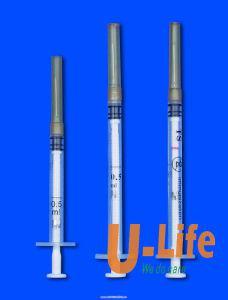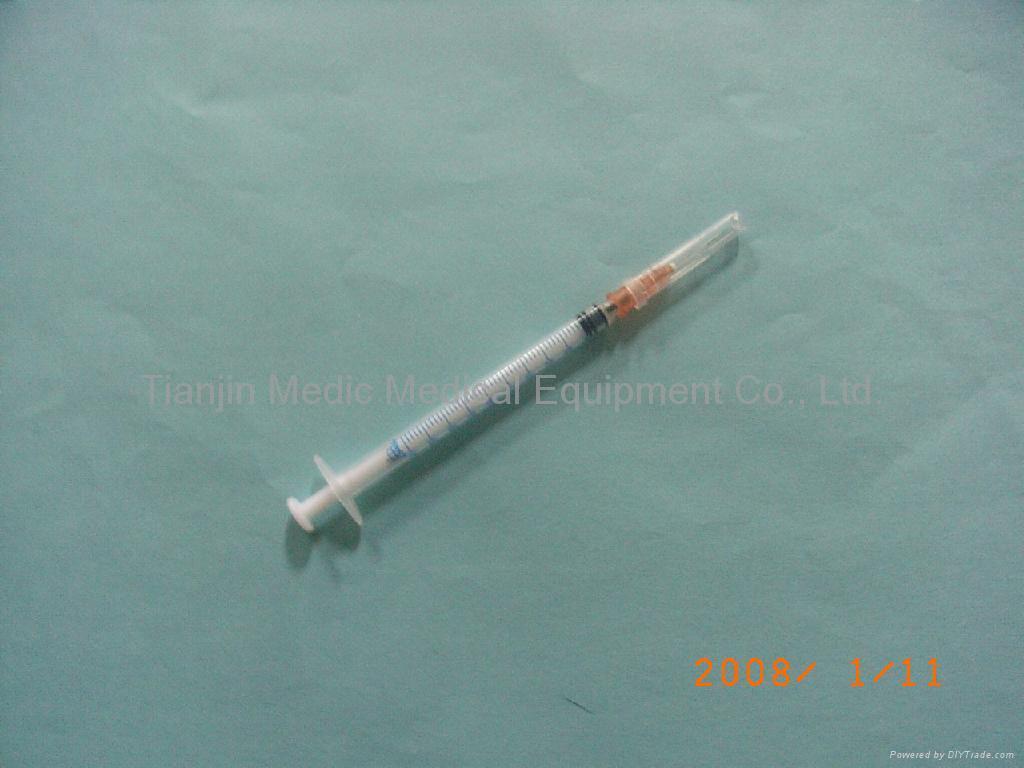The first image is the image on the left, the second image is the image on the right. Assess this claim about the two images: "There are more needles in the right image.". Correct or not? Answer yes or no. No. The first image is the image on the left, the second image is the image on the right. Examine the images to the left and right. Is the description "There is a single syringe in one of the images and at least twice as many in the other." accurate? Answer yes or no. Yes. 